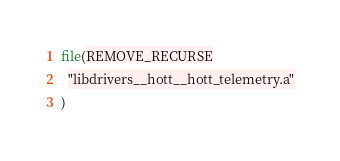<code> <loc_0><loc_0><loc_500><loc_500><_CMake_>file(REMOVE_RECURSE
  "libdrivers__hott__hott_telemetry.a"
)
</code> 